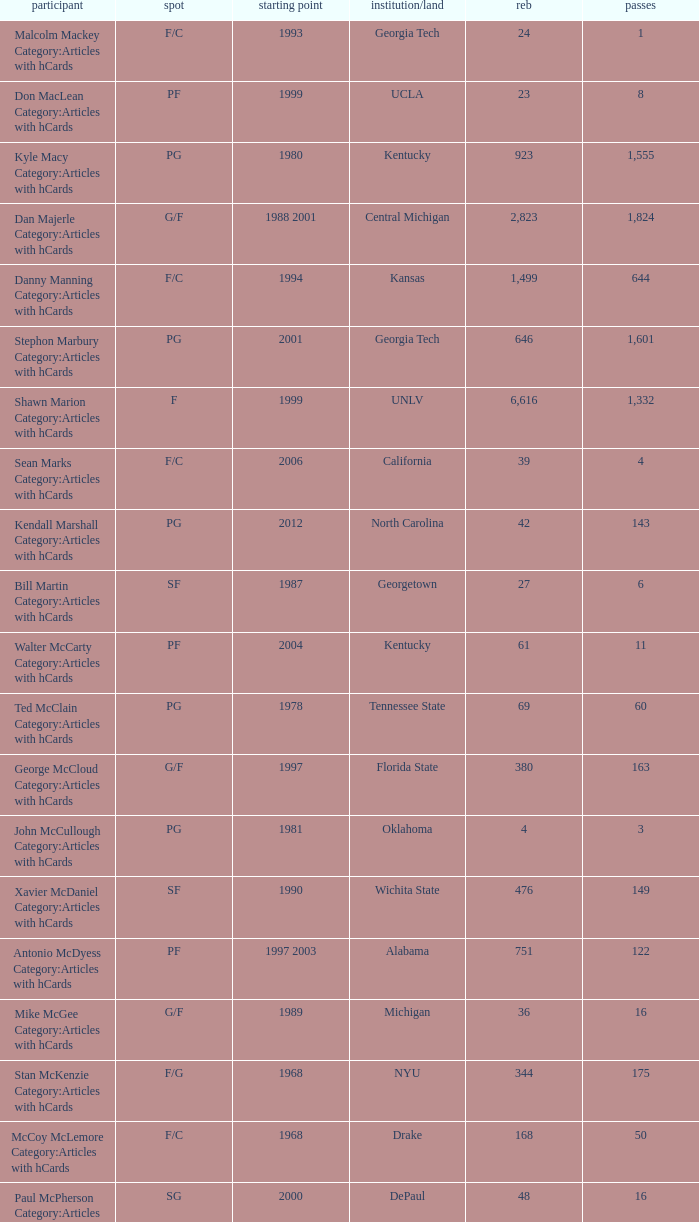What position does the player from arkansas play? C. 